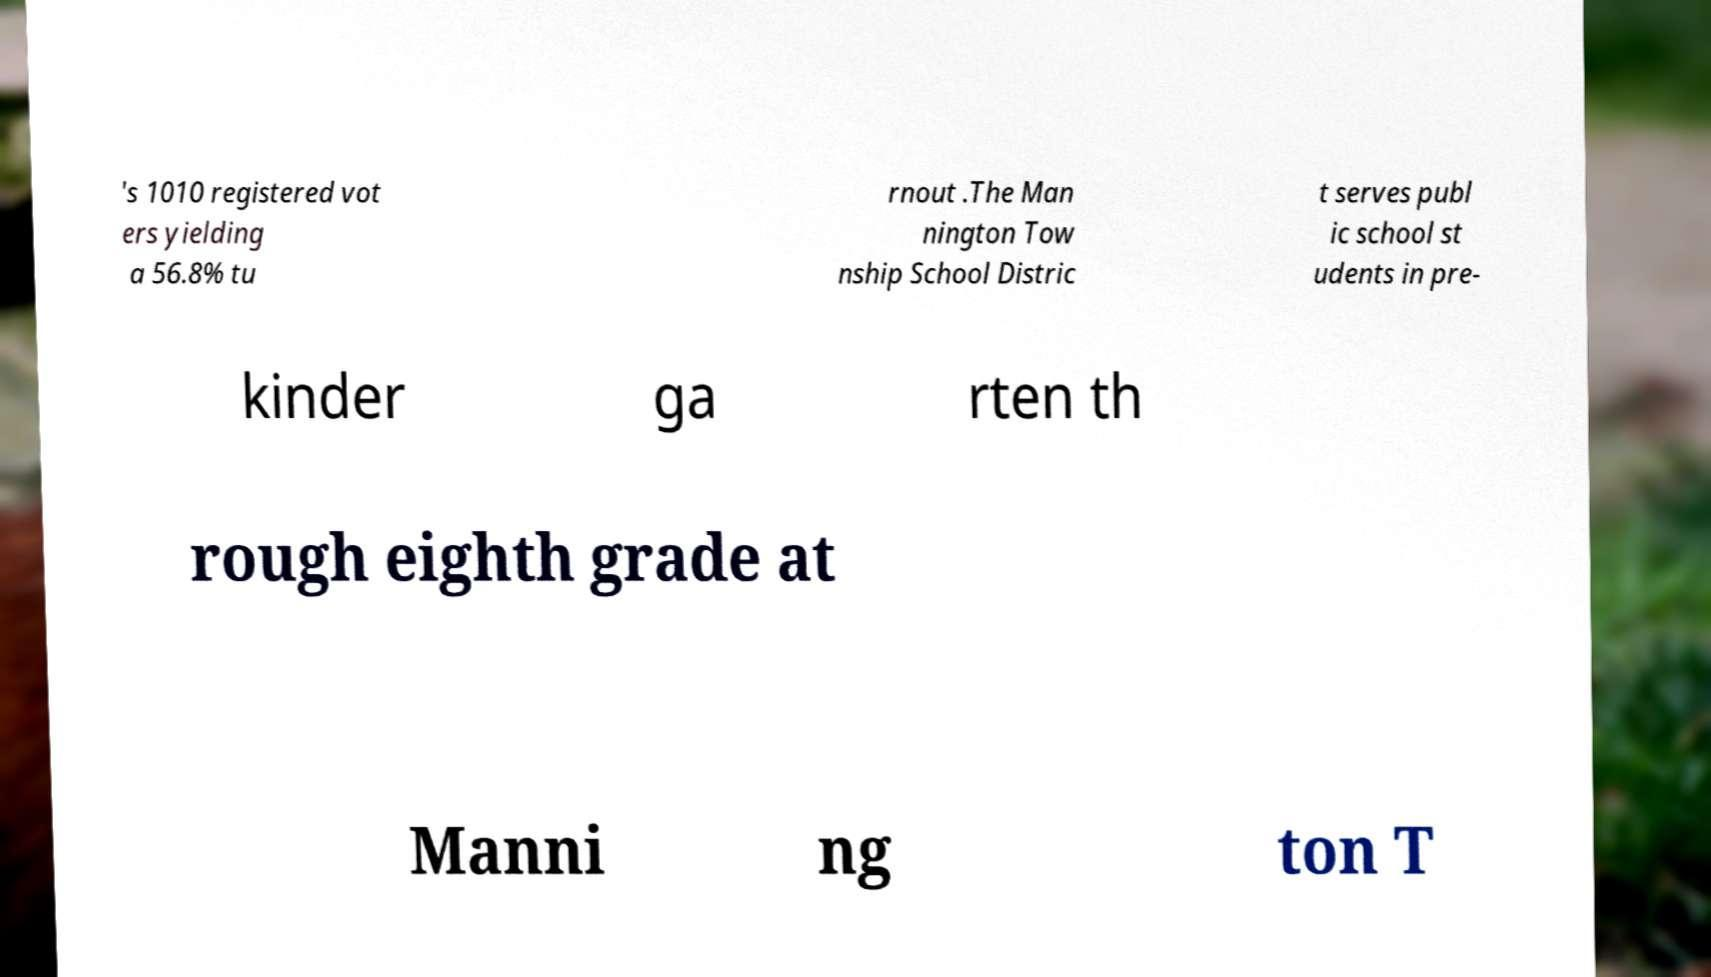Could you extract and type out the text from this image? 's 1010 registered vot ers yielding a 56.8% tu rnout .The Man nington Tow nship School Distric t serves publ ic school st udents in pre- kinder ga rten th rough eighth grade at Manni ng ton T 